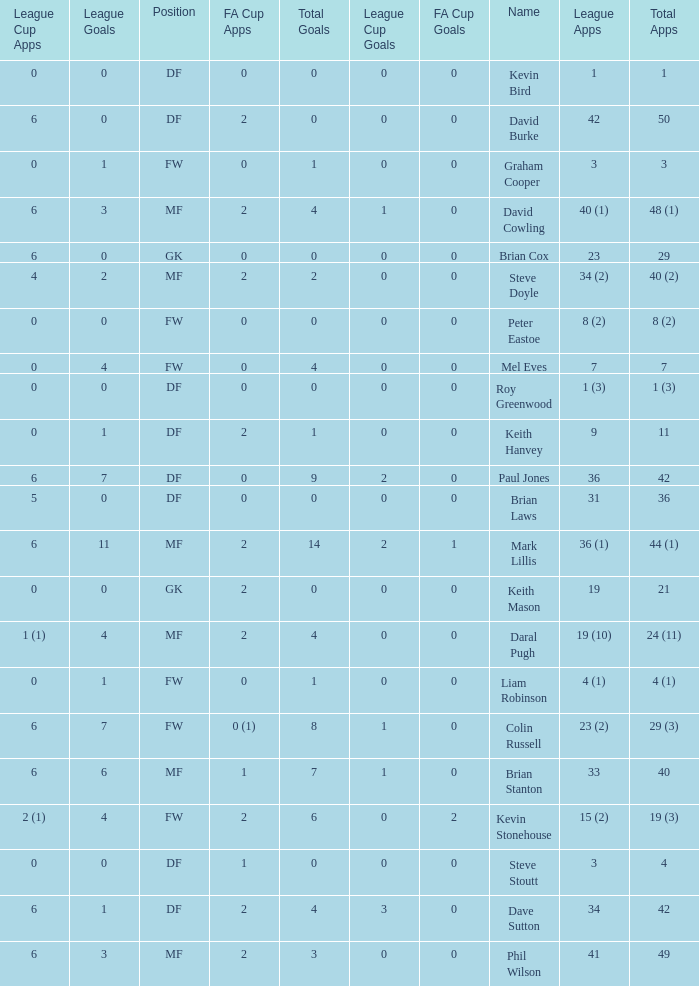What is the most total goals for a player having 0 FA Cup goals and 41 League appearances? 3.0. 